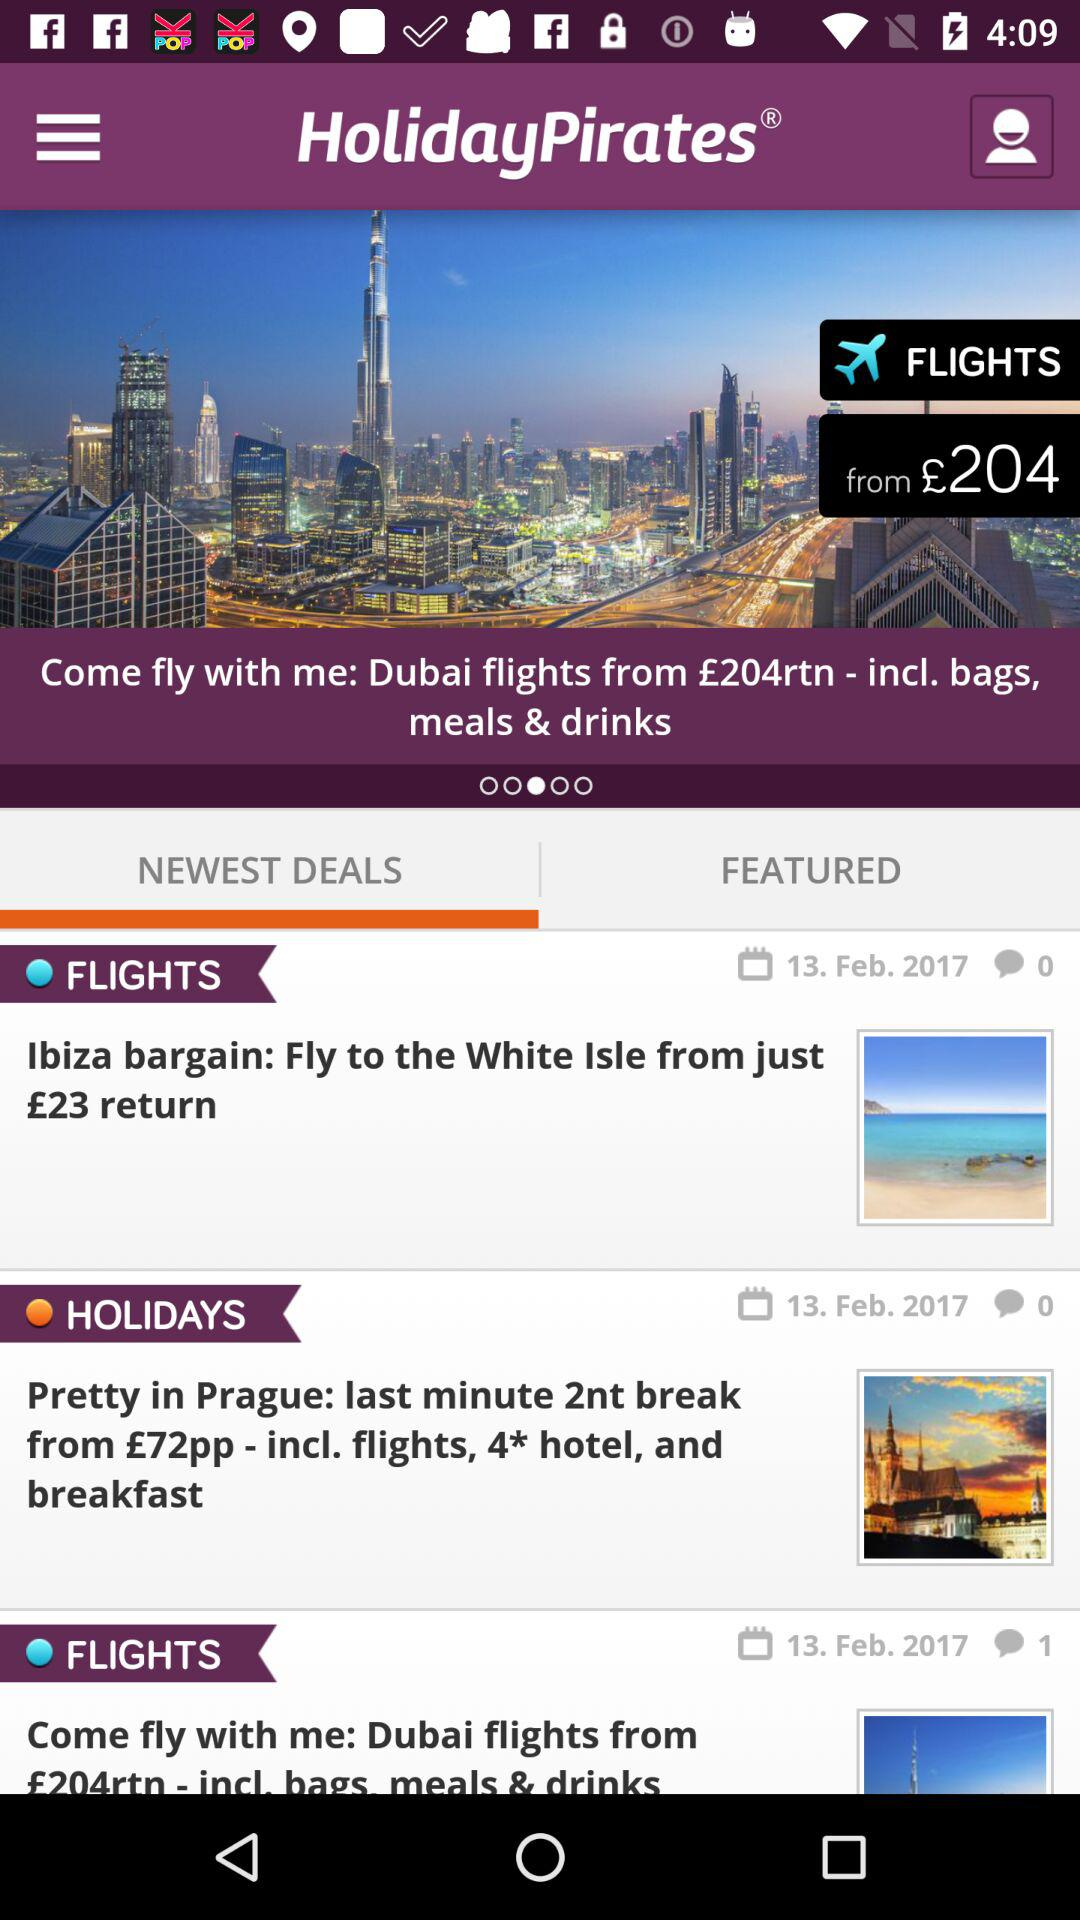What is the newest deal? The newest deals are "Ibiza bargain: Fly to the White Isle from just £23 return", "Pretty in Prague: last minute 2nt break from £72pp - incl. flights, 4* hotel, and breakfast" and "Come fly with me: Dubai flights from £204rtn - incl. bags meals & drinks". 